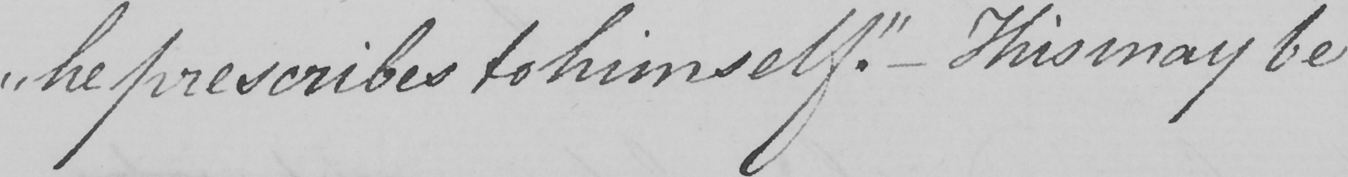Can you read and transcribe this handwriting? " he prescribes to himself . "   _  This may be 